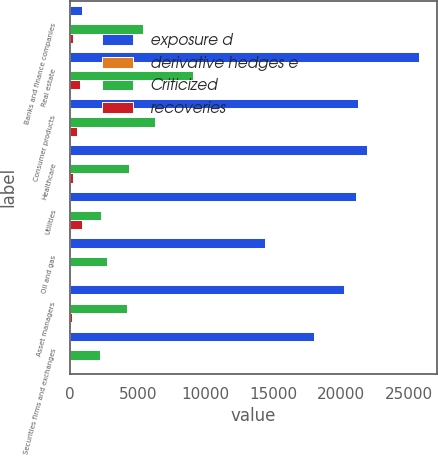Convert chart. <chart><loc_0><loc_0><loc_500><loc_500><stacked_bar_chart><ecel><fcel>Banks and finance companies<fcel>Real estate<fcel>Consumer products<fcel>Healthcare<fcel>Utilities<fcel>Oil and gas<fcel>Asset managers<fcel>Securities firms and exchanges<nl><fcel>exposure d<fcel>890<fcel>25761<fcel>21251<fcel>21890<fcel>21132<fcel>14420<fcel>20199<fcel>18034<nl><fcel>derivative hedges e<fcel>90<fcel>62<fcel>68<fcel>79<fcel>85<fcel>81<fcel>79<fcel>88<nl><fcel>Criticized<fcel>5348<fcel>9036<fcel>6267<fcel>4321<fcel>2316<fcel>2713<fcel>4192<fcel>2218<nl><fcel>recoveries<fcel>187<fcel>765<fcel>479<fcel>249<fcel>890<fcel>51<fcel>115<fcel>17<nl></chart> 